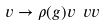<formula> <loc_0><loc_0><loc_500><loc_500>v \rightarrow \rho ( g ) v \ v v</formula> 